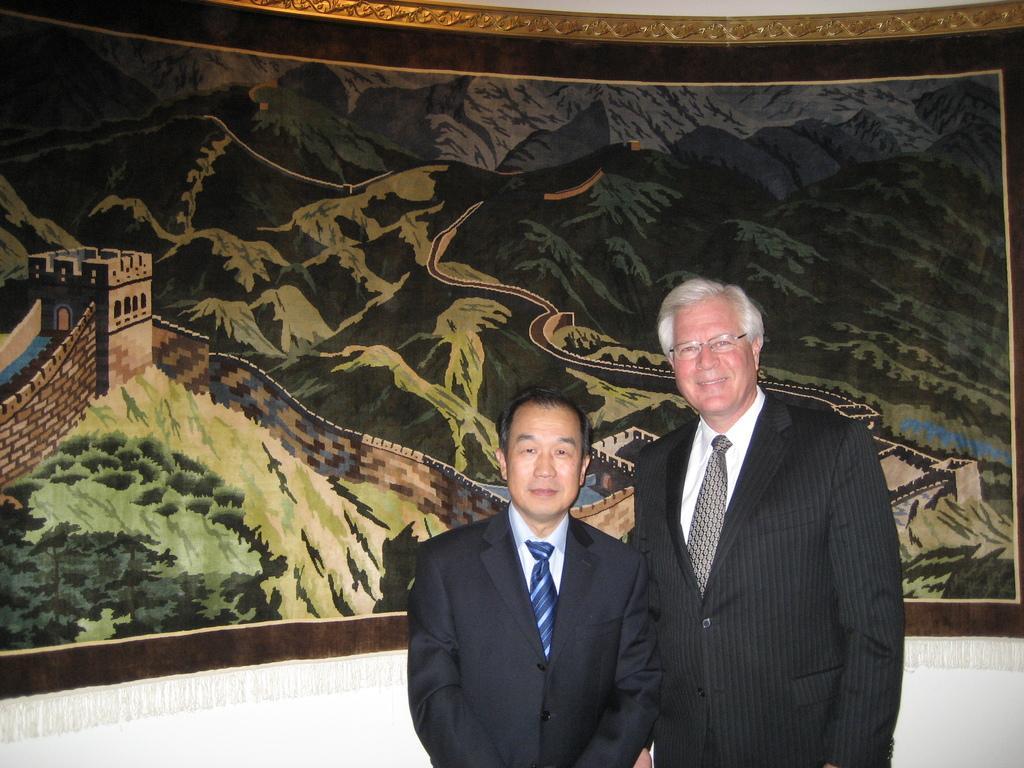Can you describe this image briefly? In this picture I can see two people wearing the coat and standing. I can see printed design curtain in the background. 